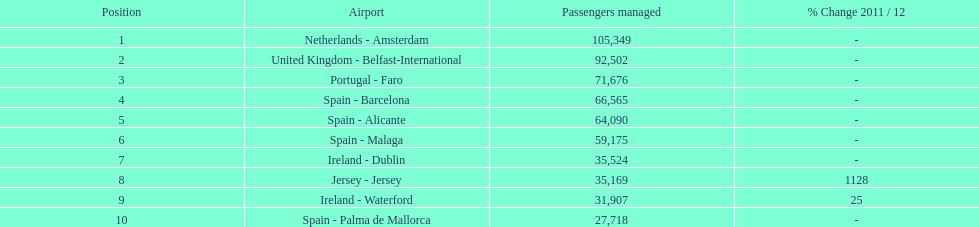Which airport had more passengers handled than the united kingdom? Netherlands - Amsterdam. 